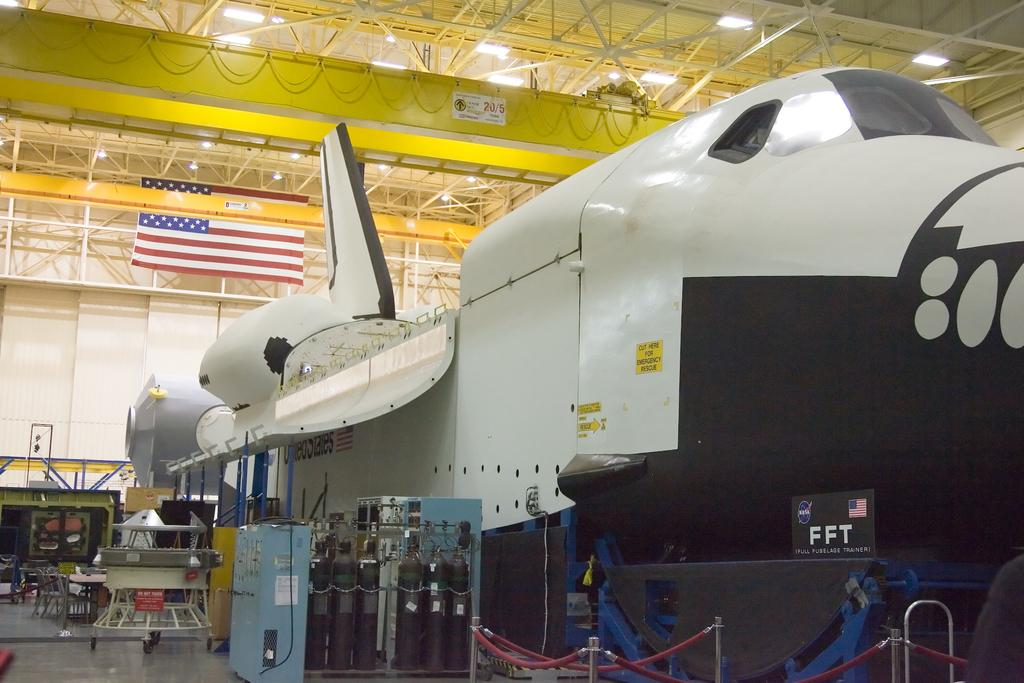<image>
Render a clear and concise summary of the photo. A space shuttle with a sticker that says "Cut here for emergency rescue." 